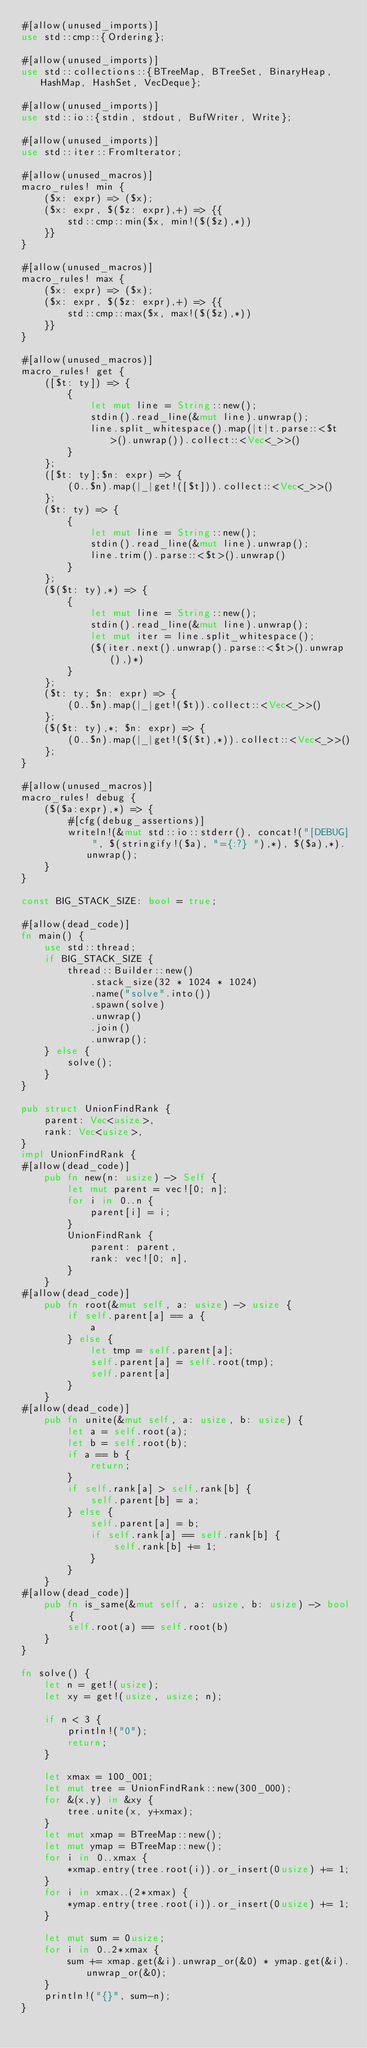<code> <loc_0><loc_0><loc_500><loc_500><_Rust_>#[allow(unused_imports)]
use std::cmp::{Ordering};

#[allow(unused_imports)]
use std::collections::{BTreeMap, BTreeSet, BinaryHeap, HashMap, HashSet, VecDeque};

#[allow(unused_imports)]
use std::io::{stdin, stdout, BufWriter, Write};

#[allow(unused_imports)]
use std::iter::FromIterator;

#[allow(unused_macros)]
macro_rules! min {
    ($x: expr) => ($x);
    ($x: expr, $($z: expr),+) => {{
        std::cmp::min($x, min!($($z),*))
    }}
}

#[allow(unused_macros)]
macro_rules! max {
    ($x: expr) => ($x);
    ($x: expr, $($z: expr),+) => {{
        std::cmp::max($x, max!($($z),*))
    }}
}

#[allow(unused_macros)]
macro_rules! get { 
    ([$t: ty]) => { 
        { 
            let mut line = String::new(); 
            stdin().read_line(&mut line).unwrap(); 
            line.split_whitespace().map(|t|t.parse::<$t>().unwrap()).collect::<Vec<_>>()
        }
    };
    ([$t: ty];$n: expr) => {
        (0..$n).map(|_|get!([$t])).collect::<Vec<_>>()
    };
    ($t: ty) => {
        {
            let mut line = String::new();
            stdin().read_line(&mut line).unwrap();
            line.trim().parse::<$t>().unwrap()
        }
    };
    ($($t: ty),*) => {
        { 
            let mut line = String::new();
            stdin().read_line(&mut line).unwrap();
            let mut iter = line.split_whitespace();
            ($(iter.next().unwrap().parse::<$t>().unwrap(),)*)
        }
    };
    ($t: ty; $n: expr) => {
        (0..$n).map(|_|get!($t)).collect::<Vec<_>>()
    };
    ($($t: ty),*; $n: expr) => {
        (0..$n).map(|_|get!($($t),*)).collect::<Vec<_>>()
    };
}

#[allow(unused_macros)]
macro_rules! debug {
    ($($a:expr),*) => {
        #[cfg(debug_assertions)]
        writeln!(&mut std::io::stderr(), concat!("[DEBUG] ", $(stringify!($a), "={:?} "),*), $($a),*).unwrap();
    }
}

const BIG_STACK_SIZE: bool = true;

#[allow(dead_code)]
fn main() {
    use std::thread;
    if BIG_STACK_SIZE {
        thread::Builder::new()
            .stack_size(32 * 1024 * 1024)
            .name("solve".into())
            .spawn(solve)
            .unwrap()
            .join()
            .unwrap();
    } else {
        solve();
    }
}

pub struct UnionFindRank {
    parent: Vec<usize>,
    rank: Vec<usize>,
}
impl UnionFindRank {
#[allow(dead_code)]
    pub fn new(n: usize) -> Self {
        let mut parent = vec![0; n];
        for i in 0..n {
            parent[i] = i;
        }
        UnionFindRank {
            parent: parent,
            rank: vec![0; n],
        }
    }
#[allow(dead_code)]
    pub fn root(&mut self, a: usize) -> usize {
        if self.parent[a] == a {
            a
        } else {
            let tmp = self.parent[a];
            self.parent[a] = self.root(tmp);
            self.parent[a]
        }
    }
#[allow(dead_code)]
    pub fn unite(&mut self, a: usize, b: usize) {
        let a = self.root(a);
        let b = self.root(b);
        if a == b {
            return;
        }
        if self.rank[a] > self.rank[b] {
            self.parent[b] = a;
        } else {
            self.parent[a] = b;
            if self.rank[a] == self.rank[b] {
                self.rank[b] += 1;
            }
        }
    }
#[allow(dead_code)]
    pub fn is_same(&mut self, a: usize, b: usize) -> bool {
        self.root(a) == self.root(b)
    }
}

fn solve() {
    let n = get!(usize);
    let xy = get!(usize, usize; n);

    if n < 3 {
        println!("0");
        return;
    }

    let xmax = 100_001;
    let mut tree = UnionFindRank::new(300_000);
    for &(x,y) in &xy {
        tree.unite(x, y+xmax);
    }
    let mut xmap = BTreeMap::new();
    let mut ymap = BTreeMap::new();
    for i in 0..xmax {
        *xmap.entry(tree.root(i)).or_insert(0usize) += 1;
    } 
    for i in xmax..(2*xmax) {
        *ymap.entry(tree.root(i)).or_insert(0usize) += 1;
    }

    let mut sum = 0usize;
    for i in 0..2*xmax {
        sum += xmap.get(&i).unwrap_or(&0) * ymap.get(&i).unwrap_or(&0);
    }
    println!("{}", sum-n);
}
</code> 